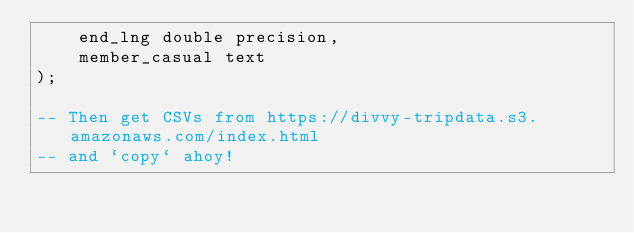<code> <loc_0><loc_0><loc_500><loc_500><_SQL_>    end_lng double precision,
    member_casual text
);

-- Then get CSVs from https://divvy-tripdata.s3.amazonaws.com/index.html
-- and `copy` ahoy!
</code> 